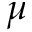<formula> <loc_0><loc_0><loc_500><loc_500>\mu</formula> 